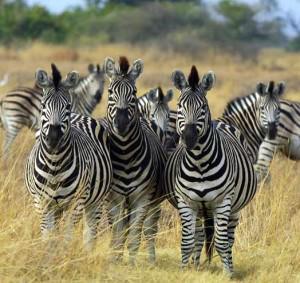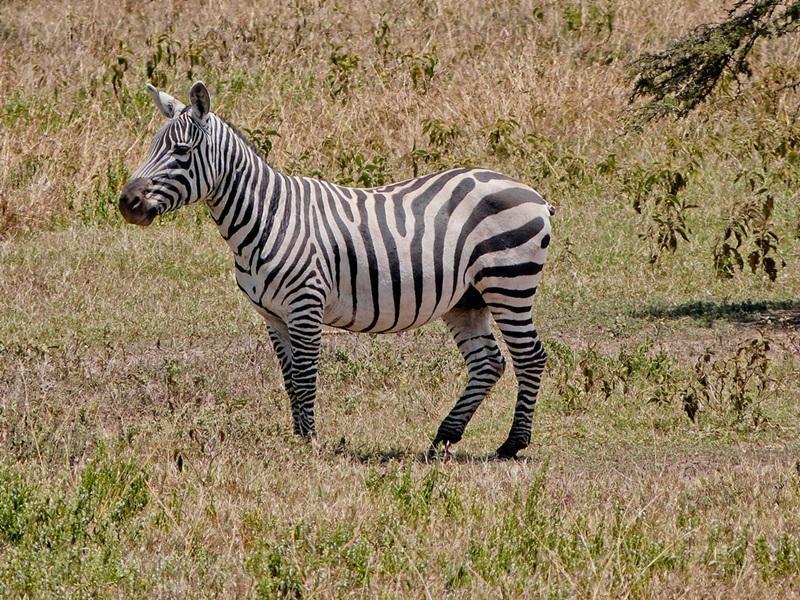The first image is the image on the left, the second image is the image on the right. Evaluate the accuracy of this statement regarding the images: "One image shows a single zebra standing in profile with its head not bent to graze, and the other image shows a close cluster of zebras facing forward and backward.". Is it true? Answer yes or no. Yes. The first image is the image on the left, the second image is the image on the right. Evaluate the accuracy of this statement regarding the images: "The right image contains no more than two zebras.". Is it true? Answer yes or no. Yes. 